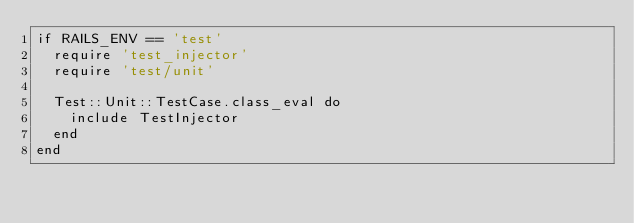<code> <loc_0><loc_0><loc_500><loc_500><_Ruby_>if RAILS_ENV == 'test'  
  require 'test_injector'
  require 'test/unit'

  Test::Unit::TestCase.class_eval do
    include TestInjector
  end
end
</code> 